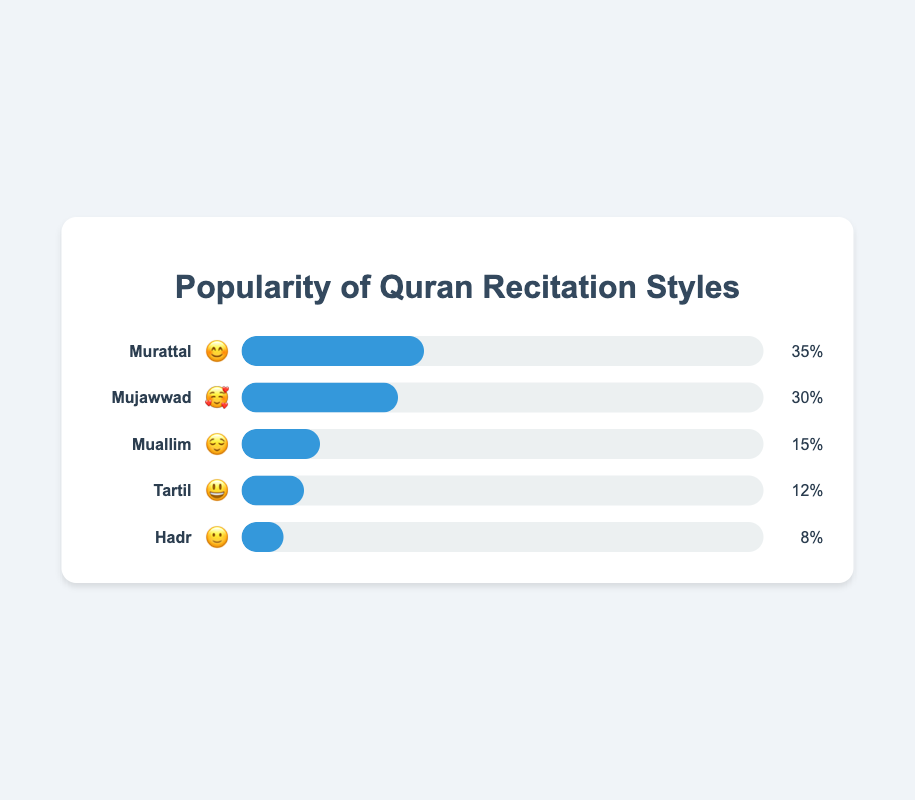What's the most popular Quran recitation style? The figure shows various recitation styles and their respective popularity percentages. The style with the highest percentage, 35%, is Murattal, as indicated by the face emoji 😊.
Answer: Murattal Which style has the lowest popularity? By reviewing the popularity percentages of each style, the lowest percentage is 8% for the Hadr style, represented by the emoji 🙂.
Answer: Hadr What is the combined popularity percentage of Mujawwad and Muallim styles? Mujawwad has 30% and Muallim has 15%. Adding these percentages together, 30% + 15% = 45%.
Answer: 45% How does the popularity of Tartil compare to Hadr? Tartil has a popularity of 12%, while Hadr has 8%. Comparing these, Tartil is more popular than Hadr.
Answer: Tartil is more popular Which style is represented by the '😌' emoji? The '😌' emoji represents the Muallim style, as indicated in the figure.
Answer: Muallim What is the difference in popularity between Murattal and Tartil styles? Murattal has a 35% popularity, and Tartil has 12%. The difference between them is 35% - 12% = 23%.
Answer: 23% Arrange the styles in descending order of popularity. Sorting the styles by their popularity percentages: Murattal (35%), Mujawwad (30%), Muallim (15%), Tartil (12%), and Hadr (8%).
Answer: Murattal, Mujawwad, Muallim, Tartil, Hadr Which two styles together make up nearly half of the total percentage? Murattal has 35% and Mujawwad has 30%. Together, they comprise 35% + 30% = 65%, which is more than half. However, Muallim and Mujawwad together make 45%, which is near half of the total.
Answer: Muallim and Mujawwad What is the sum of popularity percentages of Murattal, Mujawwad, and Tartil? Adding up the percentages: 35% (Murattal) + 30% (Mujawwad) + 12% (Tartil) = 77%.
Answer: 77% Which style is indicated by the highest popularity emoji '😊'? The '😊' emoji is used to represent the Murattal style, which has the highest popularity percentage of 35%.
Answer: Murattal 